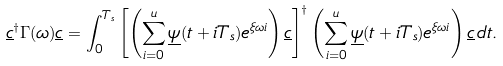Convert formula to latex. <formula><loc_0><loc_0><loc_500><loc_500>\underline { c } ^ { \dagger } \Gamma ( \omega ) \underline { c } = \int _ { 0 } ^ { T _ { s } } \left [ \left ( \sum _ { i = 0 } ^ { u } \underline { \psi } ( t + i T _ { s } ) e ^ { \xi \omega i } \right ) \underline { c } \right ] ^ { \dagger } \left ( \sum _ { i = 0 } ^ { u } \underline { \psi } ( t + i T _ { s } ) e ^ { \xi \omega i } \right ) \underline { c } \, d t .</formula> 